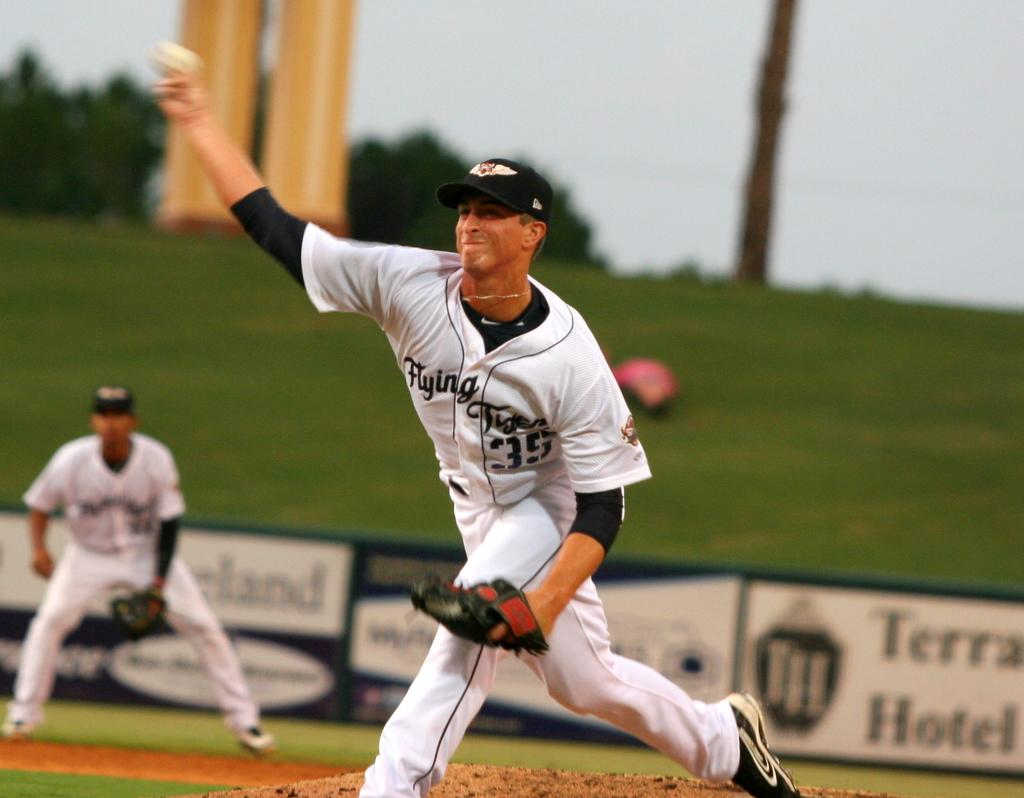<image>
Create a compact narrative representing the image presented. The player is wearing the number 35 Flying Tiger jersey. 